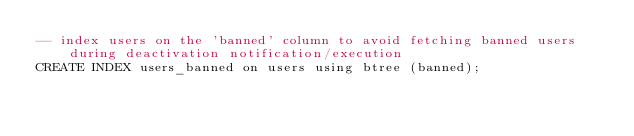<code> <loc_0><loc_0><loc_500><loc_500><_SQL_>-- index users on the 'banned' column to avoid fetching banned users during deactivation notification/execution
CREATE INDEX users_banned on users using btree (banned);
</code> 